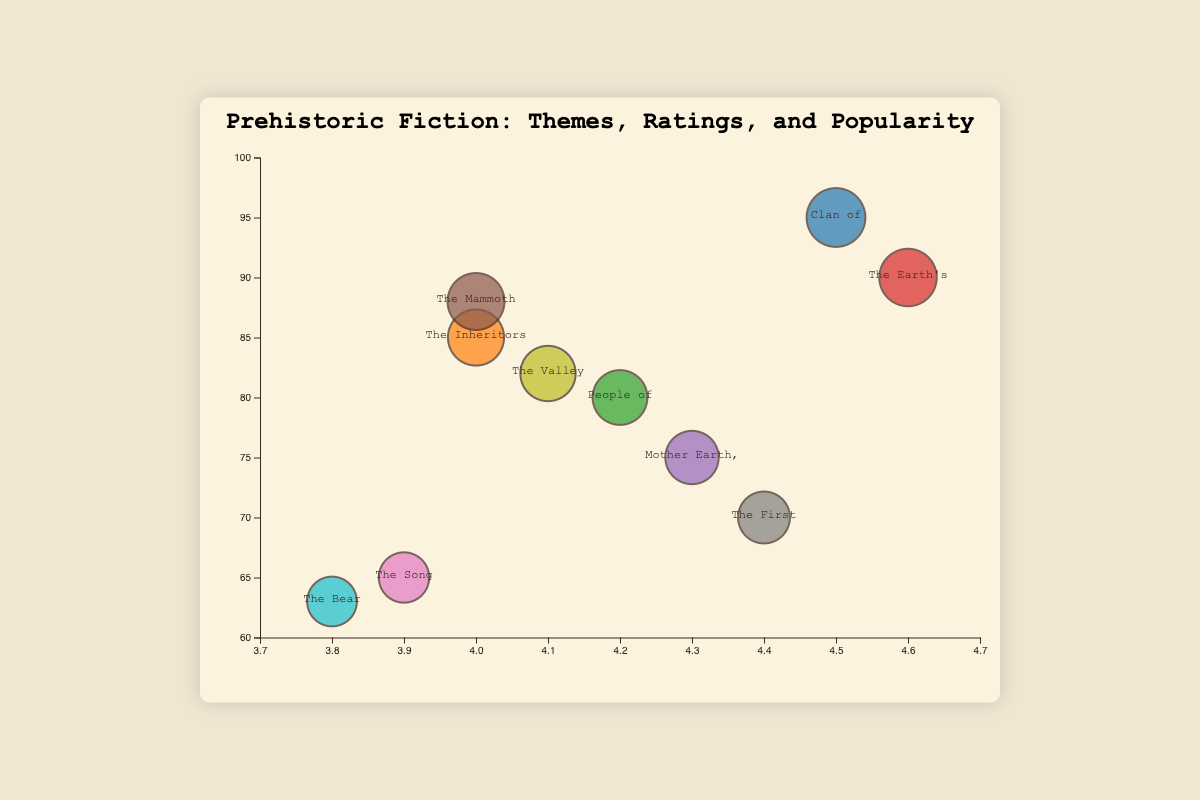What is the title of the chart? The title of the chart is found at the top center of the figure. It reads "Prehistoric Fiction: Themes, Ratings, and Popularity".
Answer: Prehistoric Fiction: Themes, Ratings, and Popularity Which book has the highest rating? The highest point on the x-axis represents the highest rating, which is 4.6. The book at this rating is noted in the text beside the bubble, which is "The Earth's Children".
Answer: The Earth's Children How many books have a popularity score above 80? Count the bubbles located above the y-axis value of 80. The books are "Clan of the Cave Bear", "The Inheritors", "The Mammoth Hunters", and "The Valley of Horses".
Answer: 4 Which themes are represented in the chart, and how are they visually distinguished? The themes are differentiated by color in the bubble chart. These themes include "Survival and Community", "Evolutionary Struggle", "Tribal Society", "Ancient Cultures", "Myth and Spirituality", "Adventure and Exploration", "Human Evolution", "Historical Exploration", "Cultural Interaction", and "Nature and Survival".
Answer: Ten themes represented by different colors What is the average rating and average popularity of Jean M. Auel's books? Jean M. Auel has four books with ratings 4.5, 4.6, 4.0, and 4.1; and popularity 95, 90, 88, and 82, respectively. Sum the ratings: 4.5 + 4.6 + 4.0 + 4.1 = 17.2. Calculate avg. rating: 17.2 / 4 = 4.3. Sum the popularity: 95 + 90 + 88 + 82 = 355. Calculate avg. popularity: 355 / 4 = 88.75.
Answer: Average rating: 4.3, Average popularity: 88.75 Which book has the smallest bubble on the chart? The size of the bubble is proportional to the popularity score. The smallest bubble corresponds to the least popularity, which is "The Bear Tribe" with a popularity of 63.
Answer: The Bear Tribe What is the difference in popularity between "The Mammoth Hunters" and "The Song of the Earth"? "The Mammoth Hunters" has a popularity score of 88, and "The Song of the Earth" has a popularity score of 65. Difference: 88 - 65 = 23.
Answer: 23 Which book on the theme "Human Evolution" has the highest rating? There's only one book on the theme "Human Evolution," namely "The Song of the Earth," and its rating is 3.9.
Answer: The Song of the Earth Compare the popularity of "The Inheritors" and "Mother Earth, Father Sky". Which one is more popular? "The Inheritors" has a popularity score of 85, whereas "Mother Earth, Father Sky" has a popularity score of 75. Therefore, "The Inheritors" is more popular.
Answer: The Inheritors What are the coordinates (rating, popularity) of "People of the Wolf"? Locate "People of the Wolf" and note its placement along the x-axis and y-axis. It has a rating of 4.2 and a popularity of 80.
Answer: (4.2, 80) 